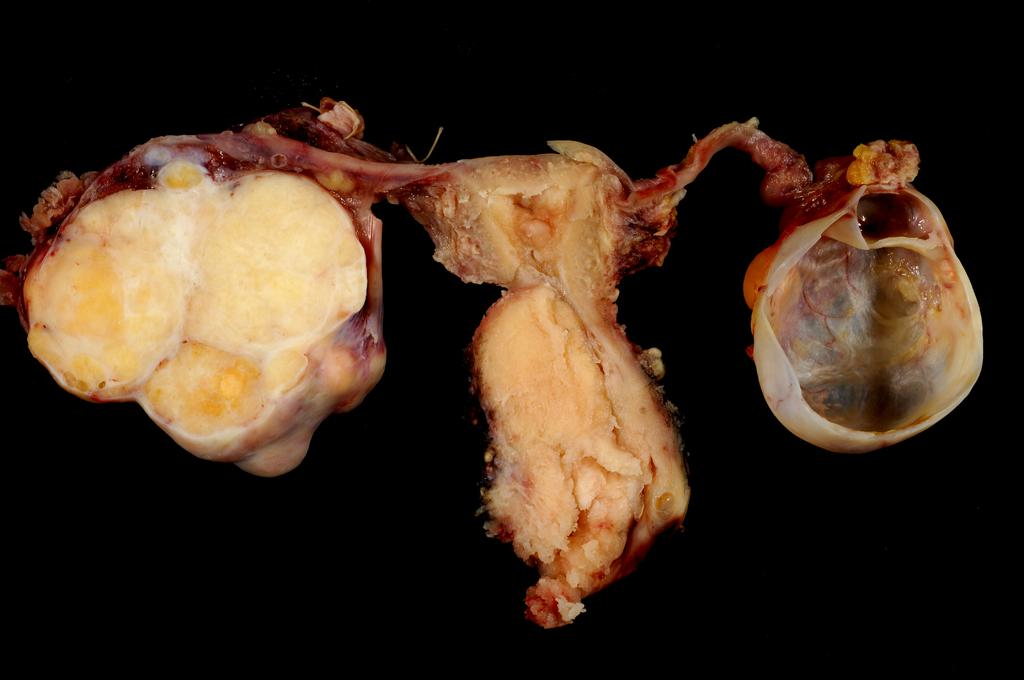What type of food is visible in the image? There is some meat in the image. What can be seen behind the meat in the image? The backdrop of the image is dark. What type of lamp is draped with a sheet in the image? There is no lamp or sheet present in the image. 